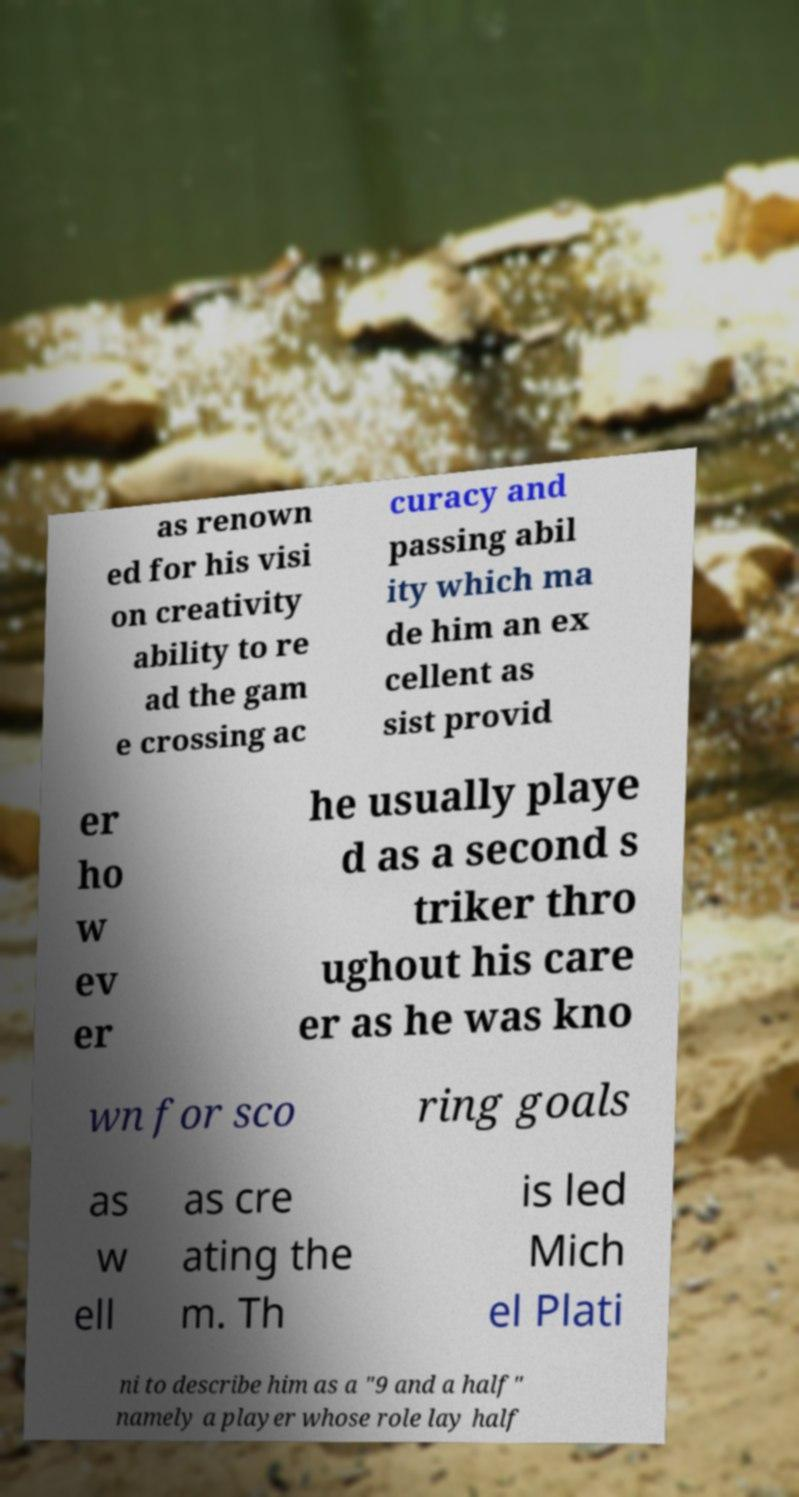Can you accurately transcribe the text from the provided image for me? as renown ed for his visi on creativity ability to re ad the gam e crossing ac curacy and passing abil ity which ma de him an ex cellent as sist provid er ho w ev er he usually playe d as a second s triker thro ughout his care er as he was kno wn for sco ring goals as w ell as cre ating the m. Th is led Mich el Plati ni to describe him as a "9 and a half" namely a player whose role lay half 